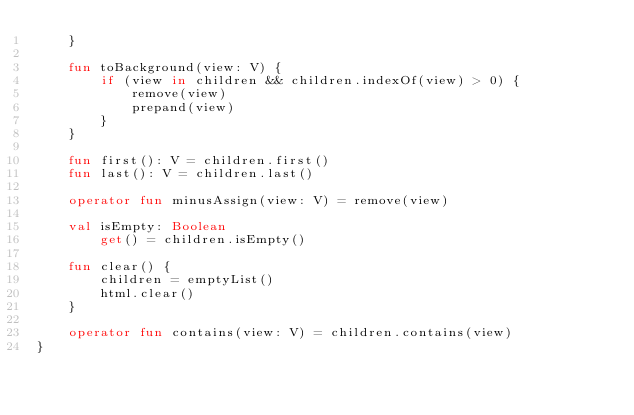Convert code to text. <code><loc_0><loc_0><loc_500><loc_500><_Kotlin_>    }

    fun toBackground(view: V) {
        if (view in children && children.indexOf(view) > 0) {
            remove(view)
            prepand(view)
        }
    }

    fun first(): V = children.first()
    fun last(): V = children.last()

    operator fun minusAssign(view: V) = remove(view)

    val isEmpty: Boolean
        get() = children.isEmpty()

    fun clear() {
        children = emptyList()
        html.clear()
    }

    operator fun contains(view: V) = children.contains(view)
}</code> 